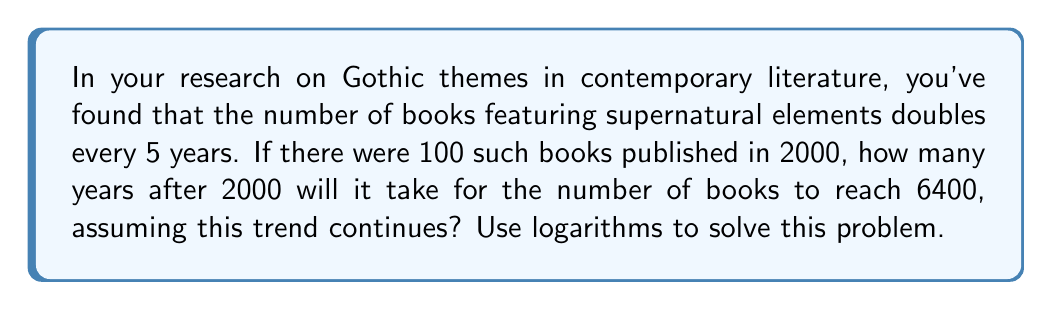Could you help me with this problem? Let's approach this step-by-step using logarithms:

1) Let $y$ be the number of years after 2000, and $N$ be the number of books.

2) We can express this relationship as:
   $N = 100 \cdot 2^{\frac{y}{5}}$

3) We want to find $y$ when $N = 6400$. So we can write:
   $6400 = 100 \cdot 2^{\frac{y}{5}}$

4) Divide both sides by 100:
   $64 = 2^{\frac{y}{5}}$

5) Now, we can apply logarithms (base 2) to both sides:
   $\log_2(64) = \log_2(2^{\frac{y}{5}})$

6) The right side simplifies due to the logarithm rule $\log_a(a^x) = x$:
   $\log_2(64) = \frac{y}{5}$

7) We know that $\log_2(64) = 6$ because $2^6 = 64$. So:
   $6 = \frac{y}{5}$

8) Multiply both sides by 5:
   $30 = y$

Therefore, it will take 30 years after 2000 for the number of books to reach 6400.
Answer: 30 years 